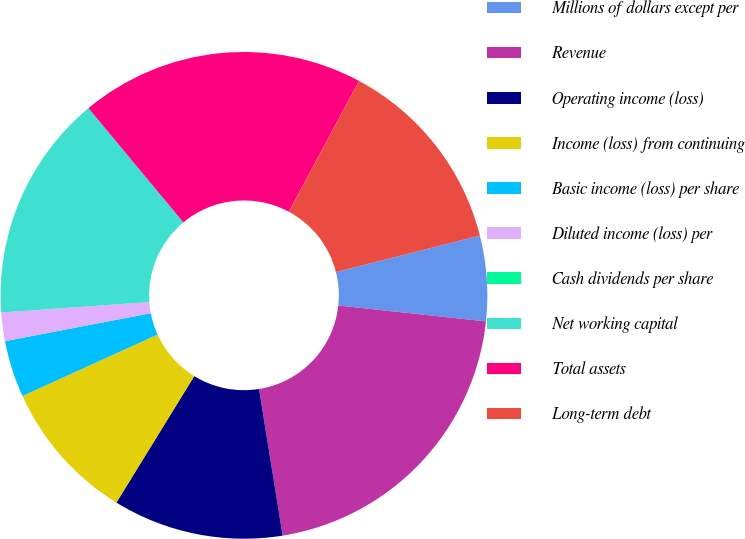<chart> <loc_0><loc_0><loc_500><loc_500><pie_chart><fcel>Millions of dollars except per<fcel>Revenue<fcel>Operating income (loss)<fcel>Income (loss) from continuing<fcel>Basic income (loss) per share<fcel>Diluted income (loss) per<fcel>Cash dividends per share<fcel>Net working capital<fcel>Total assets<fcel>Long-term debt<nl><fcel>5.66%<fcel>20.75%<fcel>11.32%<fcel>9.43%<fcel>3.77%<fcel>1.89%<fcel>0.0%<fcel>15.09%<fcel>18.87%<fcel>13.21%<nl></chart> 